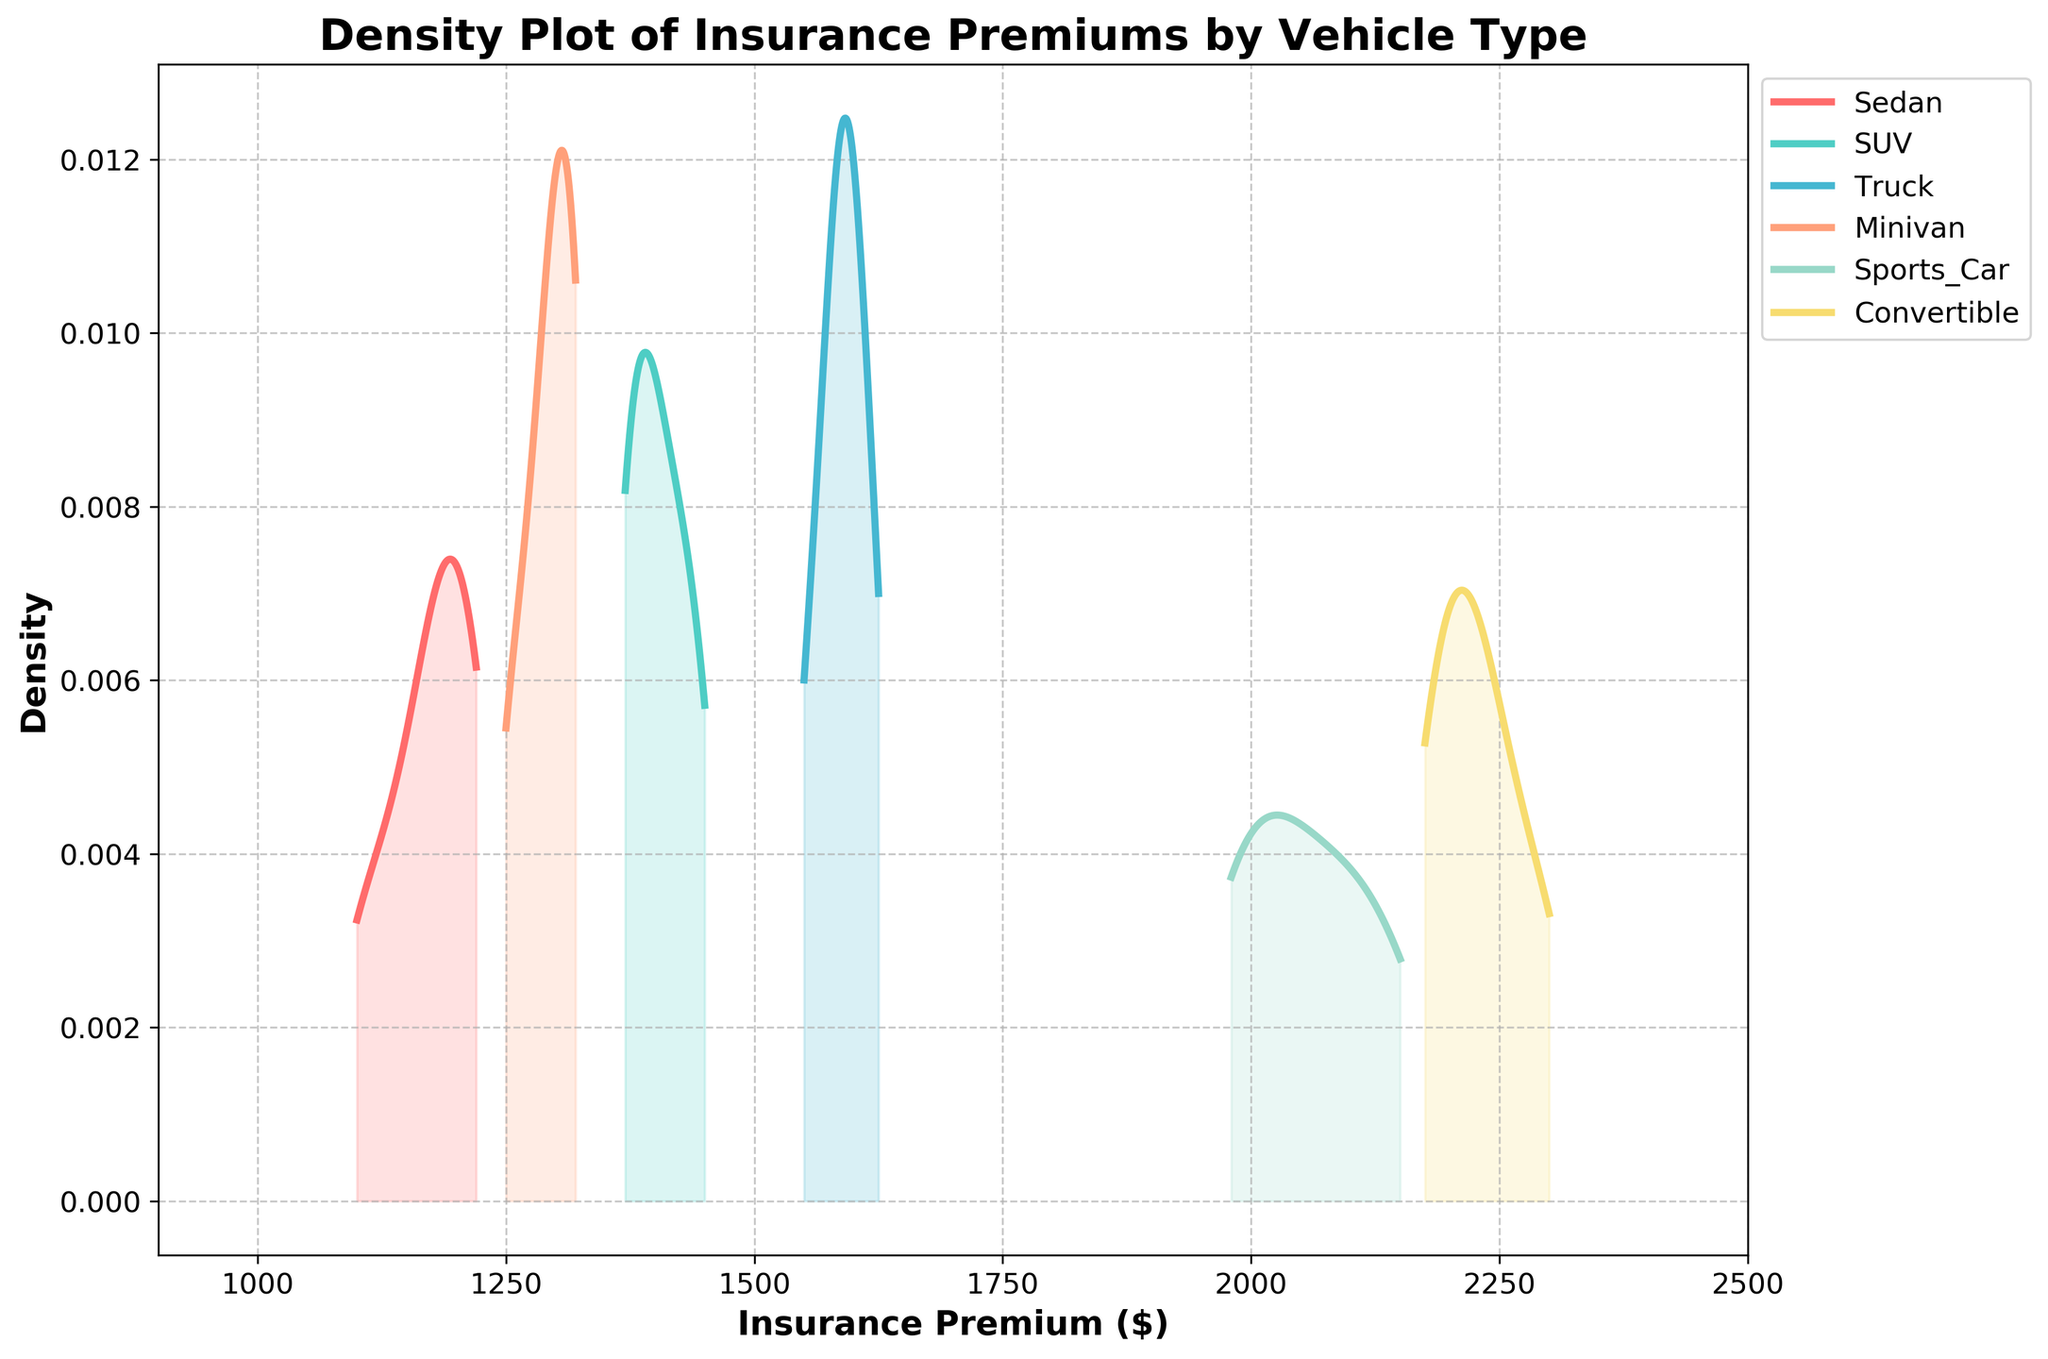What is the title of the density plot? The title is the text displayed at the top of the plot, indicating what the figure represents. In this case, it's explicitly labeled at the top and should mention the subject of the plot.
Answer: Density Plot of Insurance Premiums by Vehicle Type What is the range of insurance premiums shown on the x-axis? The range of the x-axis is represented by the minimum and maximum values at the ends of the axis, which are marked and labeled numerically.
Answer: 900 to 2500 Which vehicle type has the highest peak density for insurance premiums? The peak density for each vehicle type is the highest point of the respective curve on the plot. Observing the curves, we can see which one reaches the highest point.
Answer: Convertible How does the insurance premium distribution for SUVs compare to that of trucks? Comparing the two curves involves looking at how they overlap and where their peaks are. SUVs seem to have a lower maximum density and a lower insurance premium range compared to trucks.
Answer: SUVs have a lower peak and range than trucks Which vehicle type has the widest range of insurance premiums? The range of insurance premiums for each vehicle type can be seen from the start and end points of each curve on the x-axis. The vehicle type with the longest stretch on the x-axis has the widest range.
Answer: Convertible What can you infer about the insurance premiums for sedans? By examining the curve for sedans, we can see its peak and spread. It's relatively narrow, meaning most sedans cluster around a similar premium value.
Answer: Sedans have a narrow range around $1200 How does the density of insurance premiums for minivans compare with that of sports cars? Comparing the curves of minivans and sports cars involves looking at their peaks and spreads. Minivans have a lower peak, indicating a lower density concentration, and are generally clustered around lower premiums than sports cars.
Answer: Minivans have lower peaks and premiums than sports cars Which vehicle type has the smallest spread in insurance premiums? The spread is indicated by the width of the curve along the x-axis. The smallest spread belongs to the vehicle type whose curve covers the least range on the x-axis.
Answer: Sedans How many different vehicle types are represented in the plot? The legend of the plot lists each vehicle type that is represented by a different curve. By counting the items in the legend, we get the total number of types.
Answer: 6 What is the approximate peak density value for sports cars? The peak density value is the height of the curve on the y-axis for sports cars at its highest point. By looking at the curve for sports cars, estimate this value from the y-axis.
Answer: Approximately 0.003 